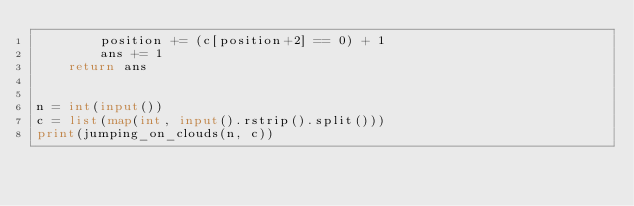Convert code to text. <code><loc_0><loc_0><loc_500><loc_500><_Python_>        position += (c[position+2] == 0) + 1
        ans += 1
    return ans


n = int(input())
c = list(map(int, input().rstrip().split()))
print(jumping_on_clouds(n, c))
</code> 